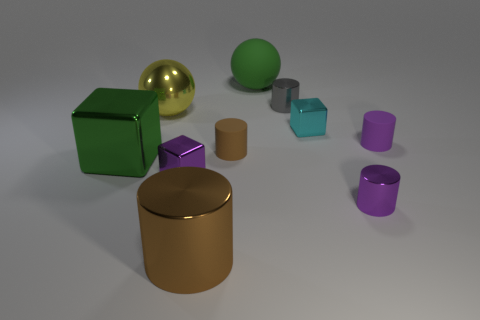The small metallic cylinder that is to the right of the cyan metal object is what color?
Keep it short and to the point. Purple. What size is the purple thing that is to the right of the purple metal cube and in front of the big green block?
Keep it short and to the point. Small. How many brown things have the same size as the yellow metal thing?
Your answer should be very brief. 1. There is a small purple object that is the same shape as the small cyan metal thing; what material is it?
Ensure brevity in your answer.  Metal. Does the tiny gray thing have the same shape as the small cyan shiny thing?
Give a very brief answer. No. What number of cyan blocks are in front of the small purple metal cylinder?
Offer a very short reply. 0. There is a object that is behind the cylinder that is behind the small cyan cube; what shape is it?
Your response must be concise. Sphere. What is the shape of the yellow object that is the same material as the large block?
Provide a short and direct response. Sphere. Does the cube that is on the right side of the gray thing have the same size as the cylinder behind the small cyan thing?
Your response must be concise. Yes. There is a tiny purple object that is behind the small brown matte cylinder; what is its shape?
Provide a short and direct response. Cylinder. 